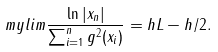<formula> <loc_0><loc_0><loc_500><loc_500>\ m y l i m \frac { \ln | x _ { n } | } { \sum _ { i = 1 } ^ { n } g ^ { 2 } ( x _ { i } ) } = h L - h / 2 .</formula> 